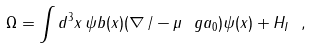<formula> <loc_0><loc_0><loc_500><loc_500>\Omega = \int d ^ { 3 } x \, \psi b ( x ) ( \nabla \, / - \mu \ g a _ { 0 } ) \psi ( x ) + H _ { I } \ ,</formula> 